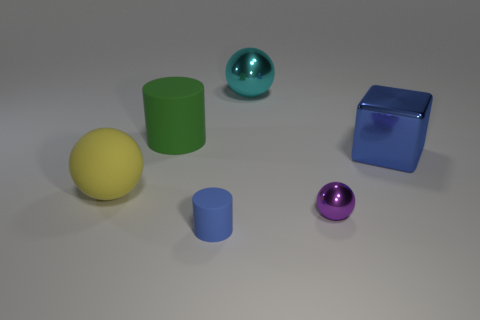Add 1 large green cylinders. How many objects exist? 7 Subtract all cylinders. How many objects are left? 4 Subtract 1 green cylinders. How many objects are left? 5 Subtract all big blue shiny blocks. Subtract all large green cylinders. How many objects are left? 4 Add 2 purple shiny balls. How many purple shiny balls are left? 3 Add 3 blue matte cylinders. How many blue matte cylinders exist? 4 